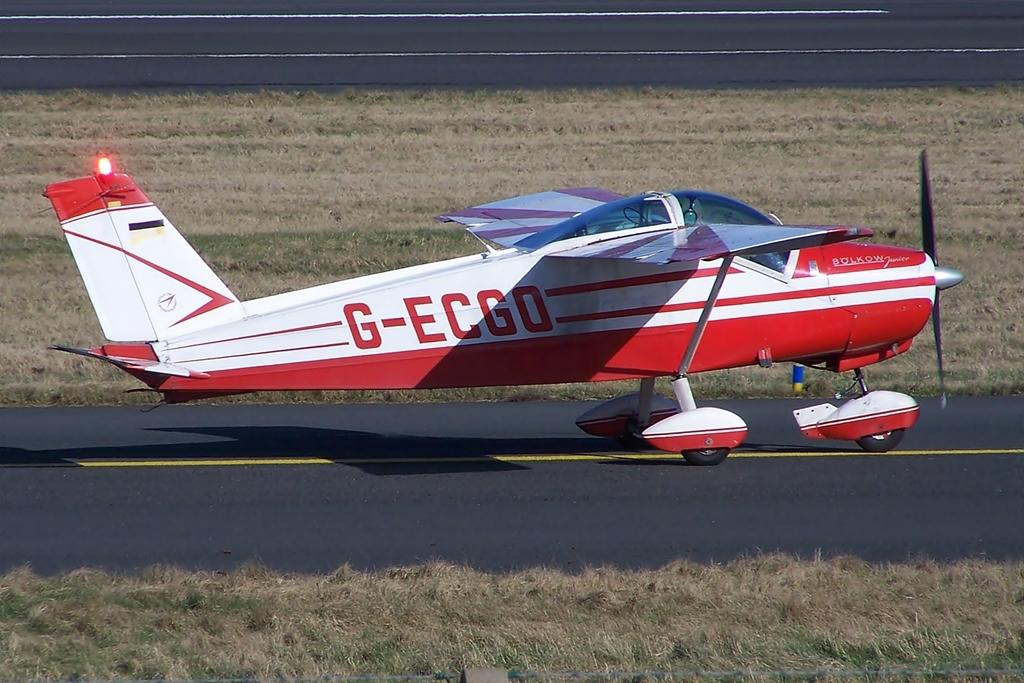<image>
Relay a brief, clear account of the picture shown. the red and white G-ECGO plane is ready to take off 